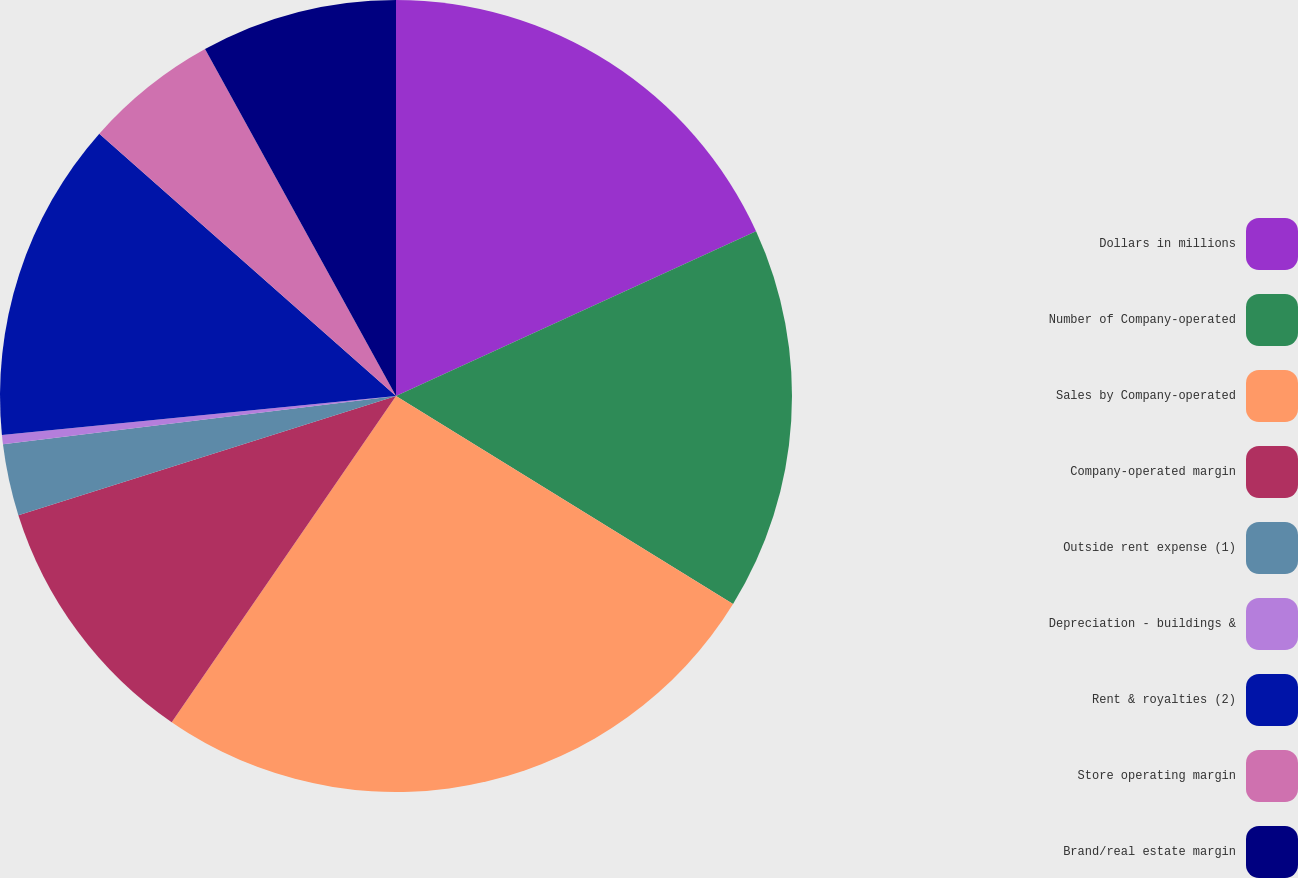Convert chart to OTSL. <chart><loc_0><loc_0><loc_500><loc_500><pie_chart><fcel>Dollars in millions<fcel>Number of Company-operated<fcel>Sales by Company-operated<fcel>Company-operated margin<fcel>Outside rent expense (1)<fcel>Depreciation - buildings &<fcel>Rent & royalties (2)<fcel>Store operating margin<fcel>Brand/real estate margin<nl><fcel>18.17%<fcel>15.63%<fcel>25.79%<fcel>10.55%<fcel>2.92%<fcel>0.38%<fcel>13.09%<fcel>5.47%<fcel>8.01%<nl></chart> 